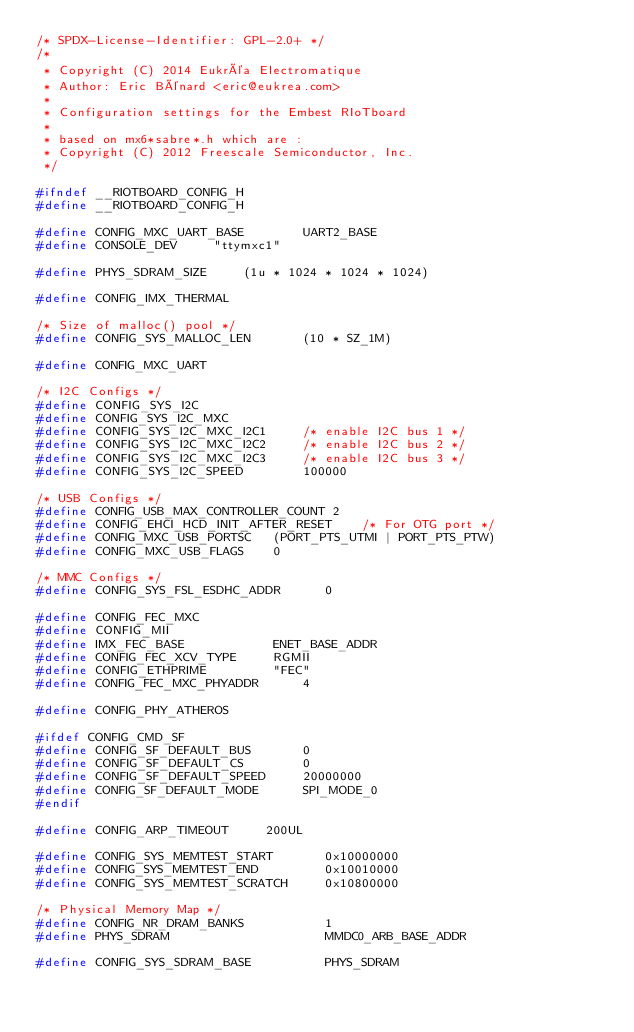Convert code to text. <code><loc_0><loc_0><loc_500><loc_500><_C_>/* SPDX-License-Identifier: GPL-2.0+ */
/*
 * Copyright (C) 2014 Eukréa Electromatique
 * Author: Eric Bénard <eric@eukrea.com>
 *
 * Configuration settings for the Embest RIoTboard
 *
 * based on mx6*sabre*.h which are :
 * Copyright (C) 2012 Freescale Semiconductor, Inc.
 */

#ifndef __RIOTBOARD_CONFIG_H
#define __RIOTBOARD_CONFIG_H

#define CONFIG_MXC_UART_BASE		UART2_BASE
#define CONSOLE_DEV		"ttymxc1"

#define PHYS_SDRAM_SIZE		(1u * 1024 * 1024 * 1024)

#define CONFIG_IMX_THERMAL

/* Size of malloc() pool */
#define CONFIG_SYS_MALLOC_LEN		(10 * SZ_1M)

#define CONFIG_MXC_UART

/* I2C Configs */
#define CONFIG_SYS_I2C
#define CONFIG_SYS_I2C_MXC
#define CONFIG_SYS_I2C_MXC_I2C1		/* enable I2C bus 1 */
#define CONFIG_SYS_I2C_MXC_I2C2		/* enable I2C bus 2 */
#define CONFIG_SYS_I2C_MXC_I2C3		/* enable I2C bus 3 */
#define CONFIG_SYS_I2C_SPEED		100000

/* USB Configs */
#define CONFIG_USB_MAX_CONTROLLER_COUNT 2
#define CONFIG_EHCI_HCD_INIT_AFTER_RESET	/* For OTG port */
#define CONFIG_MXC_USB_PORTSC	(PORT_PTS_UTMI | PORT_PTS_PTW)
#define CONFIG_MXC_USB_FLAGS	0

/* MMC Configs */
#define CONFIG_SYS_FSL_ESDHC_ADDR      0

#define CONFIG_FEC_MXC
#define CONFIG_MII
#define IMX_FEC_BASE			ENET_BASE_ADDR
#define CONFIG_FEC_XCV_TYPE		RGMII
#define CONFIG_ETHPRIME			"FEC"
#define CONFIG_FEC_MXC_PHYADDR		4

#define CONFIG_PHY_ATHEROS

#ifdef CONFIG_CMD_SF
#define CONFIG_SF_DEFAULT_BUS		0
#define CONFIG_SF_DEFAULT_CS		0
#define CONFIG_SF_DEFAULT_SPEED		20000000
#define CONFIG_SF_DEFAULT_MODE		SPI_MODE_0
#endif

#define CONFIG_ARP_TIMEOUT     200UL

#define CONFIG_SYS_MEMTEST_START       0x10000000
#define CONFIG_SYS_MEMTEST_END         0x10010000
#define CONFIG_SYS_MEMTEST_SCRATCH     0x10800000

/* Physical Memory Map */
#define CONFIG_NR_DRAM_BANKS           1
#define PHYS_SDRAM                     MMDC0_ARB_BASE_ADDR

#define CONFIG_SYS_SDRAM_BASE          PHYS_SDRAM</code> 